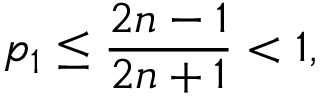<formula> <loc_0><loc_0><loc_500><loc_500>p _ { 1 } \leq \frac { 2 n - 1 } { 2 n + 1 } < 1 ,</formula> 